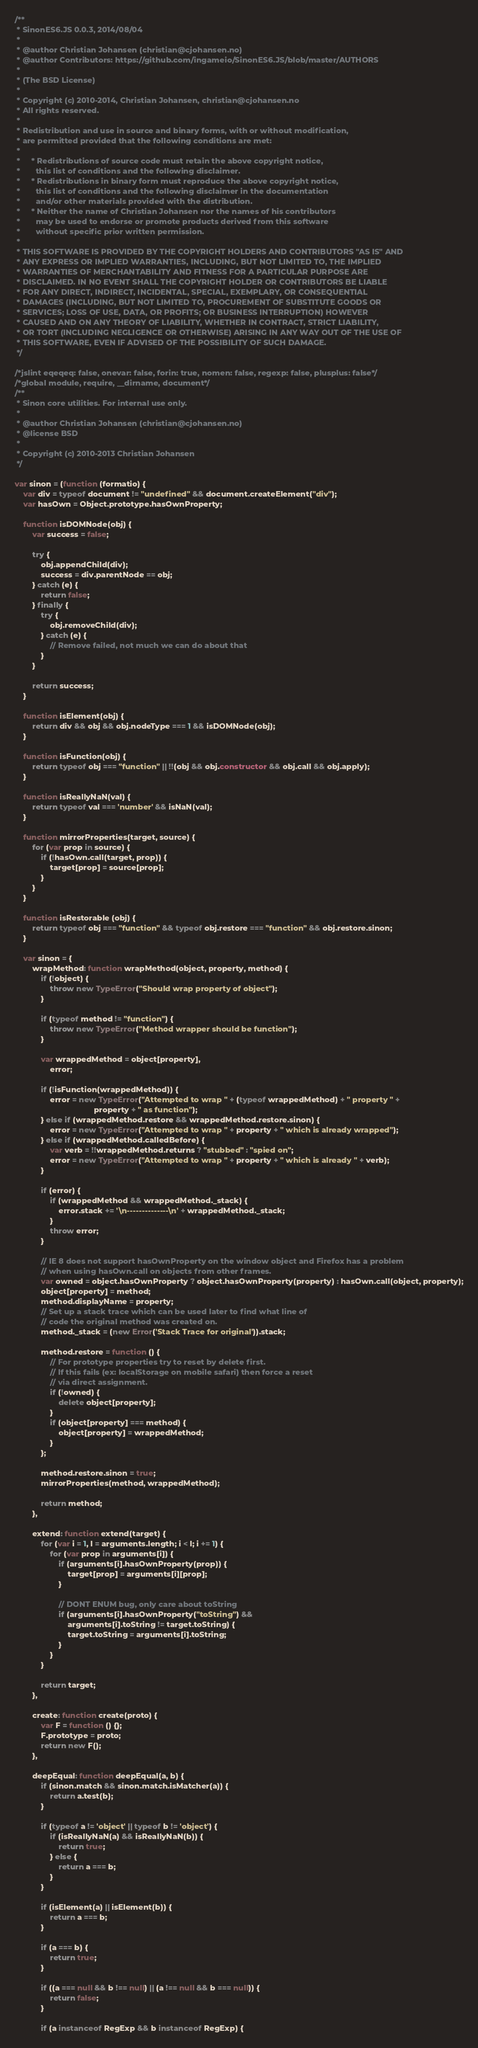Convert code to text. <code><loc_0><loc_0><loc_500><loc_500><_JavaScript_>/**
 * SinonES6.JS 0.0.3, 2014/08/04
 *
 * @author Christian Johansen (christian@cjohansen.no)
 * @author Contributors: https://github.com/ingameio/SinonES6.JS/blob/master/AUTHORS
 *
 * (The BSD License)
 * 
 * Copyright (c) 2010-2014, Christian Johansen, christian@cjohansen.no
 * All rights reserved.
 * 
 * Redistribution and use in source and binary forms, with or without modification,
 * are permitted provided that the following conditions are met:
 * 
 *     * Redistributions of source code must retain the above copyright notice,
 *       this list of conditions and the following disclaimer.
 *     * Redistributions in binary form must reproduce the above copyright notice,
 *       this list of conditions and the following disclaimer in the documentation
 *       and/or other materials provided with the distribution.
 *     * Neither the name of Christian Johansen nor the names of his contributors
 *       may be used to endorse or promote products derived from this software
 *       without specific prior written permission.
 * 
 * THIS SOFTWARE IS PROVIDED BY THE COPYRIGHT HOLDERS AND CONTRIBUTORS "AS IS" AND
 * ANY EXPRESS OR IMPLIED WARRANTIES, INCLUDING, BUT NOT LIMITED TO, THE IMPLIED
 * WARRANTIES OF MERCHANTABILITY AND FITNESS FOR A PARTICULAR PURPOSE ARE
 * DISCLAIMED. IN NO EVENT SHALL THE COPYRIGHT HOLDER OR CONTRIBUTORS BE LIABLE
 * FOR ANY DIRECT, INDIRECT, INCIDENTAL, SPECIAL, EXEMPLARY, OR CONSEQUENTIAL
 * DAMAGES (INCLUDING, BUT NOT LIMITED TO, PROCUREMENT OF SUBSTITUTE GOODS OR
 * SERVICES; LOSS OF USE, DATA, OR PROFITS; OR BUSINESS INTERRUPTION) HOWEVER
 * CAUSED AND ON ANY THEORY OF LIABILITY, WHETHER IN CONTRACT, STRICT LIABILITY,
 * OR TORT (INCLUDING NEGLIGENCE OR OTHERWISE) ARISING IN ANY WAY OUT OF THE USE OF
 * THIS SOFTWARE, EVEN IF ADVISED OF THE POSSIBILITY OF SUCH DAMAGE.
 */

/*jslint eqeqeq: false, onevar: false, forin: true, nomen: false, regexp: false, plusplus: false*/
/*global module, require, __dirname, document*/
/**
 * Sinon core utilities. For internal use only.
 *
 * @author Christian Johansen (christian@cjohansen.no)
 * @license BSD
 *
 * Copyright (c) 2010-2013 Christian Johansen
 */

var sinon = (function (formatio) {
    var div = typeof document != "undefined" && document.createElement("div");
    var hasOwn = Object.prototype.hasOwnProperty;

    function isDOMNode(obj) {
        var success = false;

        try {
            obj.appendChild(div);
            success = div.parentNode == obj;
        } catch (e) {
            return false;
        } finally {
            try {
                obj.removeChild(div);
            } catch (e) {
                // Remove failed, not much we can do about that
            }
        }

        return success;
    }

    function isElement(obj) {
        return div && obj && obj.nodeType === 1 && isDOMNode(obj);
    }

    function isFunction(obj) {
        return typeof obj === "function" || !!(obj && obj.constructor && obj.call && obj.apply);
    }

    function isReallyNaN(val) {
        return typeof val === 'number' && isNaN(val);
    }

    function mirrorProperties(target, source) {
        for (var prop in source) {
            if (!hasOwn.call(target, prop)) {
                target[prop] = source[prop];
            }
        }
    }

    function isRestorable (obj) {
        return typeof obj === "function" && typeof obj.restore === "function" && obj.restore.sinon;
    }

    var sinon = {
        wrapMethod: function wrapMethod(object, property, method) {
            if (!object) {
                throw new TypeError("Should wrap property of object");
            }

            if (typeof method != "function") {
                throw new TypeError("Method wrapper should be function");
            }

            var wrappedMethod = object[property],
                error;

            if (!isFunction(wrappedMethod)) {
                error = new TypeError("Attempted to wrap " + (typeof wrappedMethod) + " property " +
                                    property + " as function");
            } else if (wrappedMethod.restore && wrappedMethod.restore.sinon) {
                error = new TypeError("Attempted to wrap " + property + " which is already wrapped");
            } else if (wrappedMethod.calledBefore) {
                var verb = !!wrappedMethod.returns ? "stubbed" : "spied on";
                error = new TypeError("Attempted to wrap " + property + " which is already " + verb);
            }

            if (error) {
                if (wrappedMethod && wrappedMethod._stack) {
                    error.stack += '\n--------------\n' + wrappedMethod._stack;
                }
                throw error;
            }

            // IE 8 does not support hasOwnProperty on the window object and Firefox has a problem
            // when using hasOwn.call on objects from other frames.
            var owned = object.hasOwnProperty ? object.hasOwnProperty(property) : hasOwn.call(object, property);
            object[property] = method;
            method.displayName = property;
            // Set up a stack trace which can be used later to find what line of
            // code the original method was created on.
            method._stack = (new Error('Stack Trace for original')).stack;

            method.restore = function () {
                // For prototype properties try to reset by delete first.
                // If this fails (ex: localStorage on mobile safari) then force a reset
                // via direct assignment.
                if (!owned) {
                    delete object[property];
                }
                if (object[property] === method) {
                    object[property] = wrappedMethod;
                }
            };

            method.restore.sinon = true;
            mirrorProperties(method, wrappedMethod);

            return method;
        },

        extend: function extend(target) {
            for (var i = 1, l = arguments.length; i < l; i += 1) {
                for (var prop in arguments[i]) {
                    if (arguments[i].hasOwnProperty(prop)) {
                        target[prop] = arguments[i][prop];
                    }

                    // DONT ENUM bug, only care about toString
                    if (arguments[i].hasOwnProperty("toString") &&
                        arguments[i].toString != target.toString) {
                        target.toString = arguments[i].toString;
                    }
                }
            }

            return target;
        },

        create: function create(proto) {
            var F = function () {};
            F.prototype = proto;
            return new F();
        },

        deepEqual: function deepEqual(a, b) {
            if (sinon.match && sinon.match.isMatcher(a)) {
                return a.test(b);
            }

            if (typeof a != 'object' || typeof b != 'object') {
                if (isReallyNaN(a) && isReallyNaN(b)) {
                    return true;
                } else {
                    return a === b;
                }
            }

            if (isElement(a) || isElement(b)) {
                return a === b;
            }

            if (a === b) {
                return true;
            }

            if ((a === null && b !== null) || (a !== null && b === null)) {
                return false;
            }

            if (a instanceof RegExp && b instanceof RegExp) {</code> 